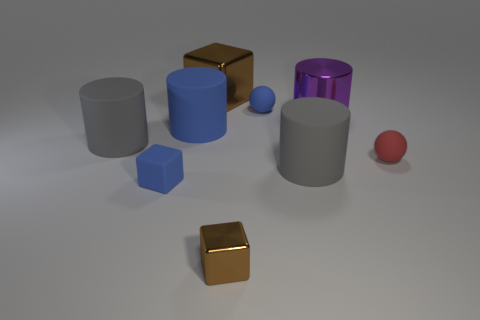There is a large thing that is in front of the large blue rubber object and behind the tiny red matte thing; what shape is it? cylinder 